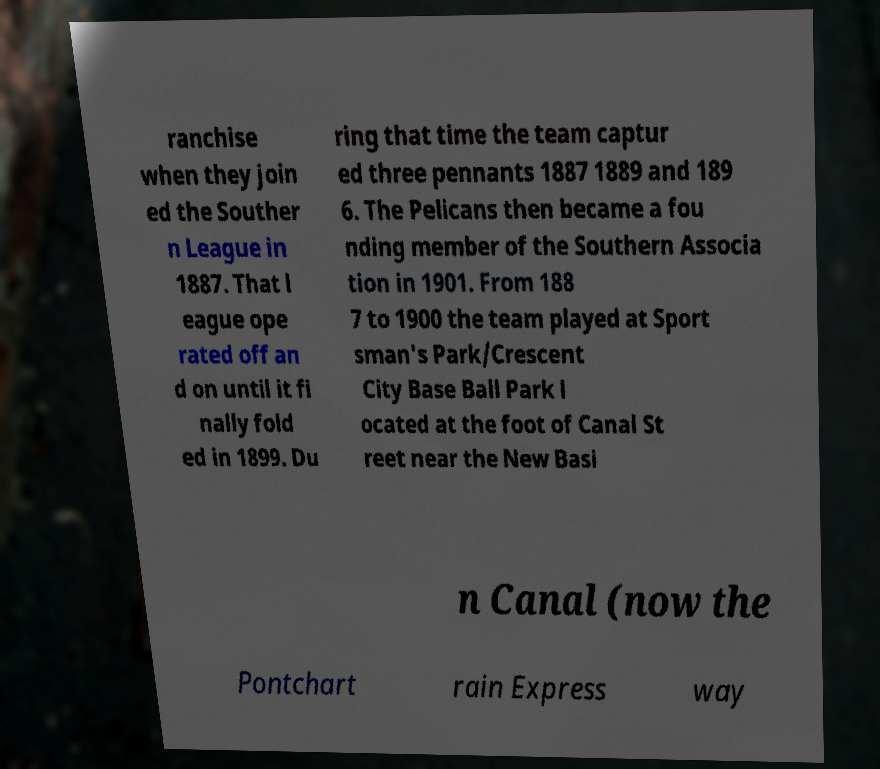There's text embedded in this image that I need extracted. Can you transcribe it verbatim? ranchise when they join ed the Souther n League in 1887. That l eague ope rated off an d on until it fi nally fold ed in 1899. Du ring that time the team captur ed three pennants 1887 1889 and 189 6. The Pelicans then became a fou nding member of the Southern Associa tion in 1901. From 188 7 to 1900 the team played at Sport sman's Park/Crescent City Base Ball Park l ocated at the foot of Canal St reet near the New Basi n Canal (now the Pontchart rain Express way 